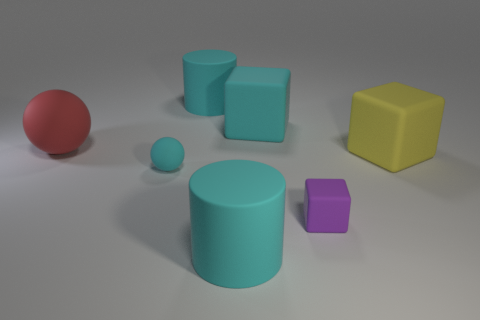What is the shape of the large cyan thing that is in front of the large red matte object that is on the left side of the yellow object?
Provide a succinct answer. Cylinder. Does the large rubber sphere have the same color as the rubber cylinder that is behind the red matte thing?
Offer a terse response. No. Are there any other things that are the same material as the big red sphere?
Ensure brevity in your answer.  Yes. What shape is the small cyan object?
Ensure brevity in your answer.  Sphere. How big is the cyan matte thing that is to the left of the big cyan rubber cylinder behind the purple rubber thing?
Your response must be concise. Small. Are there an equal number of big yellow objects that are left of the yellow matte object and small cyan balls behind the small purple cube?
Your answer should be very brief. No. There is a thing that is both behind the small matte cube and in front of the yellow thing; what is it made of?
Provide a short and direct response. Rubber. Does the yellow rubber object have the same size as the sphere that is in front of the large yellow cube?
Your answer should be compact. No. How many other things are the same color as the small matte ball?
Your response must be concise. 3. Is the number of cyan rubber blocks left of the large red rubber thing greater than the number of green metallic cubes?
Ensure brevity in your answer.  No. 